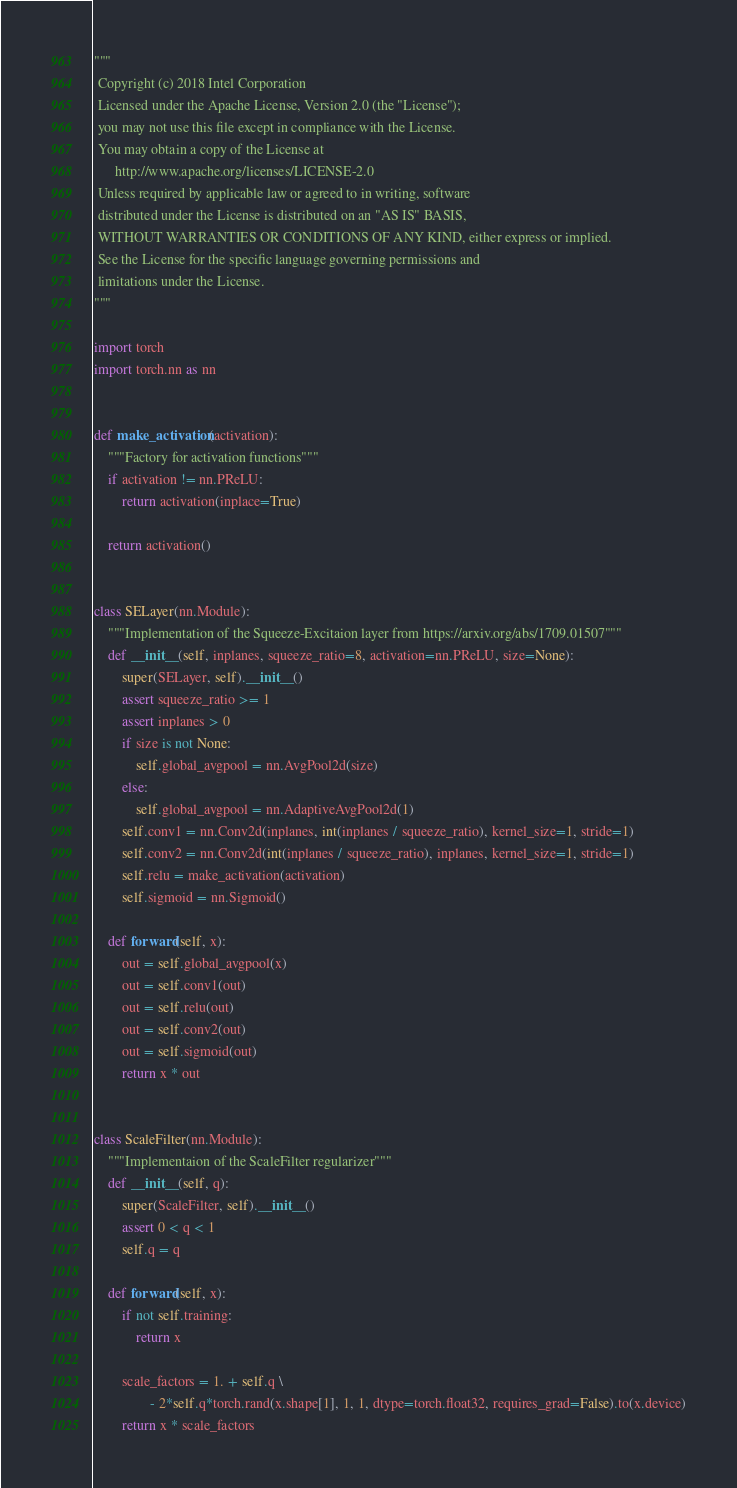Convert code to text. <code><loc_0><loc_0><loc_500><loc_500><_Python_>"""
 Copyright (c) 2018 Intel Corporation
 Licensed under the Apache License, Version 2.0 (the "License");
 you may not use this file except in compliance with the License.
 You may obtain a copy of the License at
      http://www.apache.org/licenses/LICENSE-2.0
 Unless required by applicable law or agreed to in writing, software
 distributed under the License is distributed on an "AS IS" BASIS,
 WITHOUT WARRANTIES OR CONDITIONS OF ANY KIND, either express or implied.
 See the License for the specific language governing permissions and
 limitations under the License.
"""

import torch
import torch.nn as nn


def make_activation(activation):
    """Factory for activation functions"""
    if activation != nn.PReLU:
        return activation(inplace=True)

    return activation()


class SELayer(nn.Module):
    """Implementation of the Squeeze-Excitaion layer from https://arxiv.org/abs/1709.01507"""
    def __init__(self, inplanes, squeeze_ratio=8, activation=nn.PReLU, size=None):
        super(SELayer, self).__init__()
        assert squeeze_ratio >= 1
        assert inplanes > 0
        if size is not None:
            self.global_avgpool = nn.AvgPool2d(size)
        else:
            self.global_avgpool = nn.AdaptiveAvgPool2d(1)
        self.conv1 = nn.Conv2d(inplanes, int(inplanes / squeeze_ratio), kernel_size=1, stride=1)
        self.conv2 = nn.Conv2d(int(inplanes / squeeze_ratio), inplanes, kernel_size=1, stride=1)
        self.relu = make_activation(activation)
        self.sigmoid = nn.Sigmoid()

    def forward(self, x):
        out = self.global_avgpool(x)
        out = self.conv1(out)
        out = self.relu(out)
        out = self.conv2(out)
        out = self.sigmoid(out)
        return x * out


class ScaleFilter(nn.Module):
    """Implementaion of the ScaleFilter regularizer"""
    def __init__(self, q):
        super(ScaleFilter, self).__init__()
        assert 0 < q < 1
        self.q = q

    def forward(self, x):
        if not self.training:
            return x

        scale_factors = 1. + self.q \
                - 2*self.q*torch.rand(x.shape[1], 1, 1, dtype=torch.float32, requires_grad=False).to(x.device)
        return x * scale_factors
</code> 